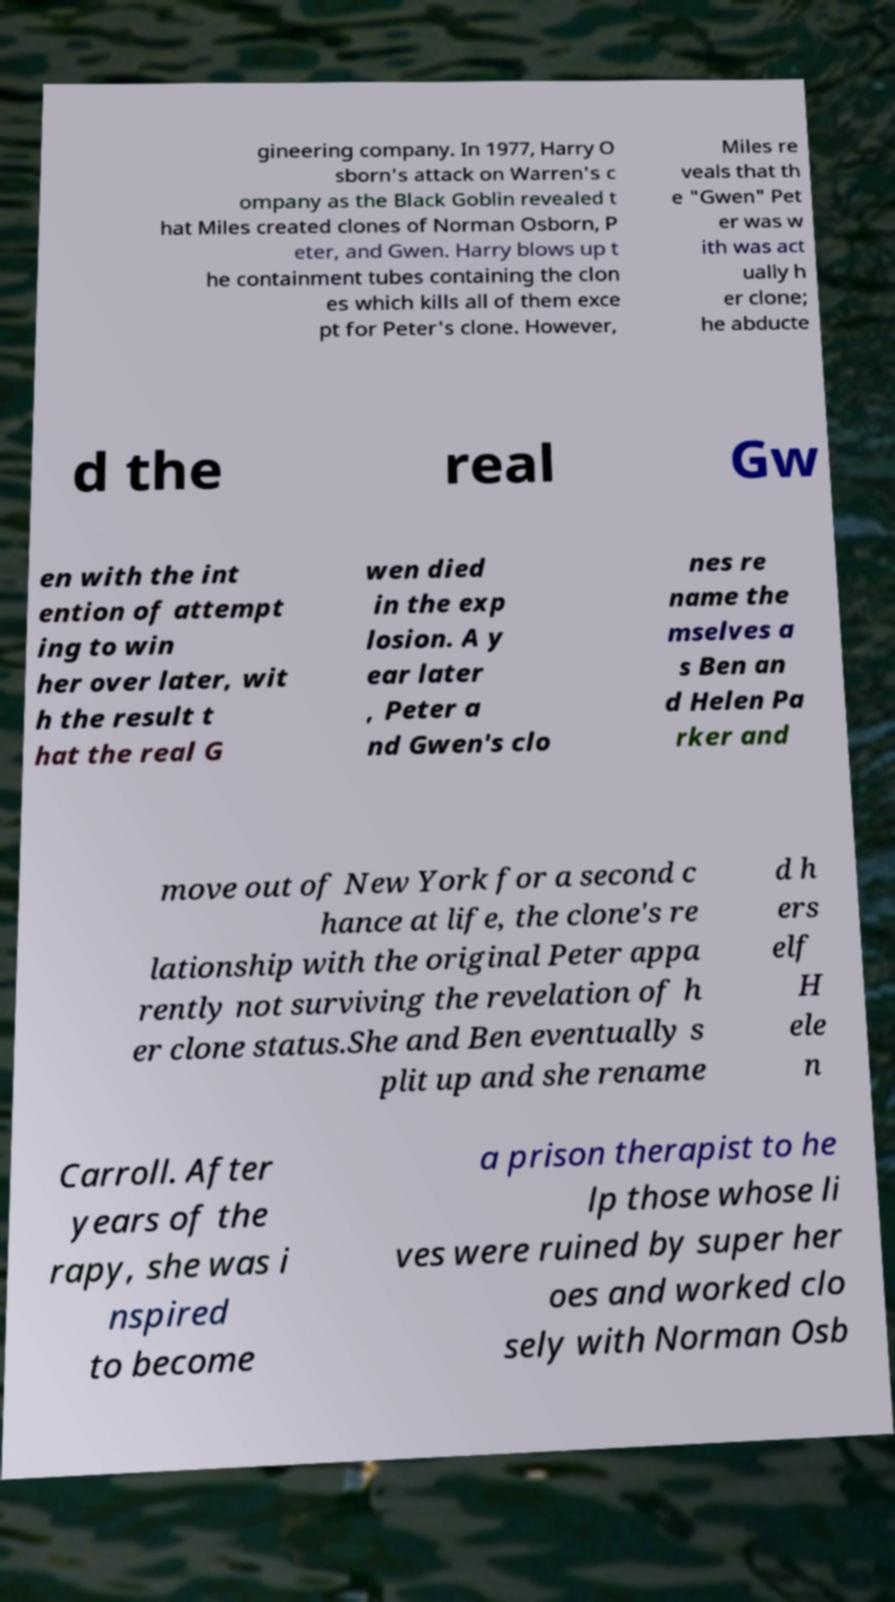Can you accurately transcribe the text from the provided image for me? gineering company. In 1977, Harry O sborn's attack on Warren's c ompany as the Black Goblin revealed t hat Miles created clones of Norman Osborn, P eter, and Gwen. Harry blows up t he containment tubes containing the clon es which kills all of them exce pt for Peter's clone. However, Miles re veals that th e "Gwen" Pet er was w ith was act ually h er clone; he abducte d the real Gw en with the int ention of attempt ing to win her over later, wit h the result t hat the real G wen died in the exp losion. A y ear later , Peter a nd Gwen's clo nes re name the mselves a s Ben an d Helen Pa rker and move out of New York for a second c hance at life, the clone's re lationship with the original Peter appa rently not surviving the revelation of h er clone status.She and Ben eventually s plit up and she rename d h ers elf H ele n Carroll. After years of the rapy, she was i nspired to become a prison therapist to he lp those whose li ves were ruined by super her oes and worked clo sely with Norman Osb 